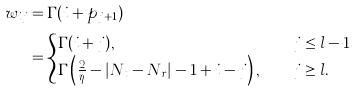<formula> <loc_0><loc_0><loc_500><loc_500>w _ { i j } & = \Gamma ( i + p _ { j + 1 } ) \\ & = \begin{cases} \Gamma ( i + j ) , \quad & j \leq l - 1 \\ \Gamma \left ( \frac { 2 } { \eta } - | N _ { t } - N _ { r } | - 1 + i - j \right ) , \quad & j \geq l . \end{cases}</formula> 